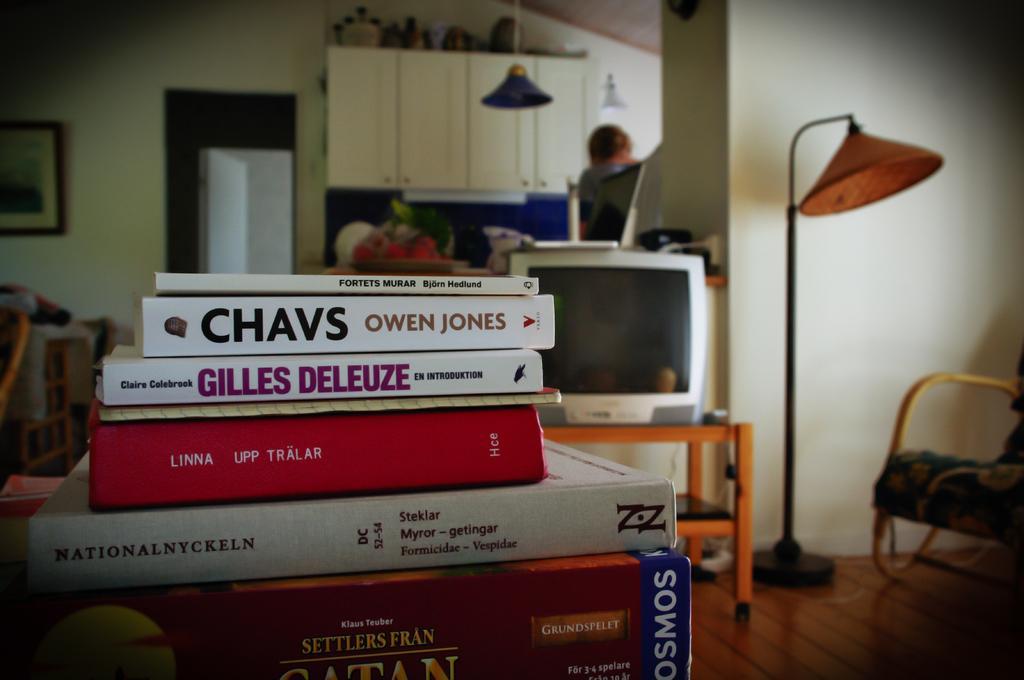Could you give a brief overview of what you see in this image? In this image I see a lot of books in front and there is a T. V. and the table over here and on the right I see a chair. In the background I see a person, laptop, cabinets and a photo frame on the wall. 